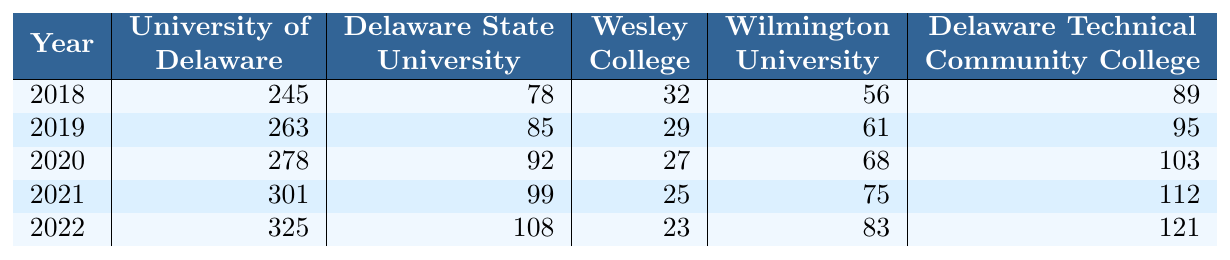What was the enrollment at the University of Delaware in 2021? The table shows the enrollment number for the University of Delaware in 2021, which is 301.
Answer: 301 Which college had the highest enrollment in environmental programs in 2022? In 2022, the enrollment numbers show that the University of Delaware had the highest enrollment at 325.
Answer: University of Delaware What is the difference in enrollment between Delaware Technical Community College and Delaware State University in 2020? The enrollment at Delaware Technical Community College in 2020 is 103, and at Delaware State University, it is 92. The difference is 103 - 92 = 11.
Answer: 11 What is the average enrollment at Wesley College over the past 5 years? The enrollments over 5 years for Wesley College are 32, 29, 27, 25, and 23. Adding these gives 32 + 29 + 27 + 25 + 23 = 136. The average is 136/5 = 27.2, which we can round to 27 when concerned with whole students.
Answer: 27 Was there an increase in enrollment at Wilmington University from 2018 to 2022? The enrollment numbers for Wilmington University are 56 in 2018 and 83 in 2022. There is an increase since 83 - 56 = 27, which is greater than zero.
Answer: Yes Which university saw the largest enrollment growth from 2018 to 2022? The enrollment at the University of Delaware grew from 245 in 2018 to 325 in 2022, a growth of 80. Delaware State University grew from 78 to 108, a growth of 30. Wilmington University grew by 27, Delaware Technical Community College by 32, and Wesley College decreased by 9. The largest growth is 80 at the University of Delaware.
Answer: University of Delaware What is the total enrollment for all colleges listed in 2019? To find the total enrollment for 2019, we sum the enrollments for each college: 263 + 85 + 29 + 61 + 95 = 533.
Answer: 533 In which year did Wesley College have the lowest enrollment? Wesley College had the lowest enrollment in 2022, with a total of 23 students.
Answer: 2022 How much did enrollment change at Delaware State University from 2018 to 2021? The enrollment at Delaware State University increased from 78 in 2018 to 99 in 2021, which is a change of 99 - 78 = 21.
Answer: 21 What was the enrollment trend for Delaware Technical Community College from 2018 to 2022? The enrollment numbers for Delaware Technical Community College from 2018 to 2022 are 89, 95, 103, 112, and 121, indicating a steady increase each year.
Answer: Increasing Is it true that enrollment in environmental programs decreased at Wesley College from 2018 to 2022? Wesley College had enrollments of 32 in 2018 and down to 23 in 2022. Since 23 is less than 32, this indicates a decrease.
Answer: Yes 